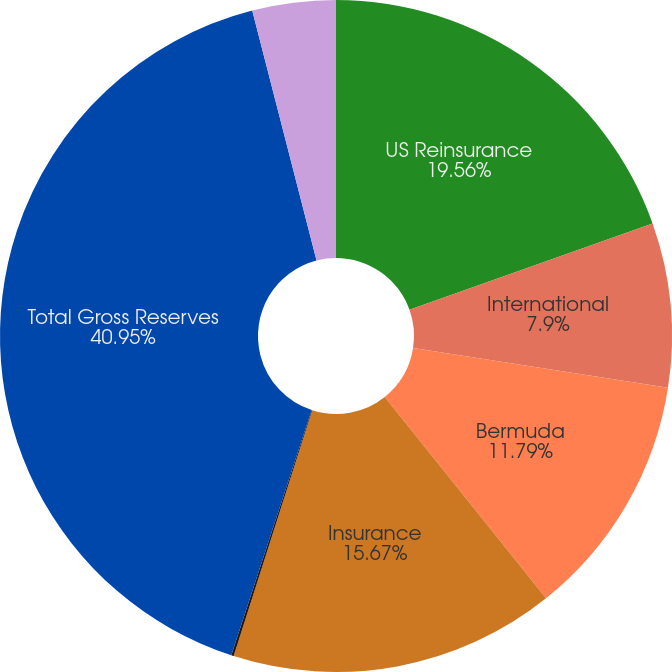Convert chart to OTSL. <chart><loc_0><loc_0><loc_500><loc_500><pie_chart><fcel>US Reinsurance<fcel>International<fcel>Bermuda<fcel>Insurance<fcel>Mt Logan Re<fcel>Total Gross Reserves<fcel>A&E (All Segments)<nl><fcel>19.56%<fcel>7.9%<fcel>11.79%<fcel>15.67%<fcel>0.12%<fcel>40.94%<fcel>4.01%<nl></chart> 